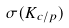<formula> <loc_0><loc_0><loc_500><loc_500>\sigma ( K _ { c / p } )</formula> 